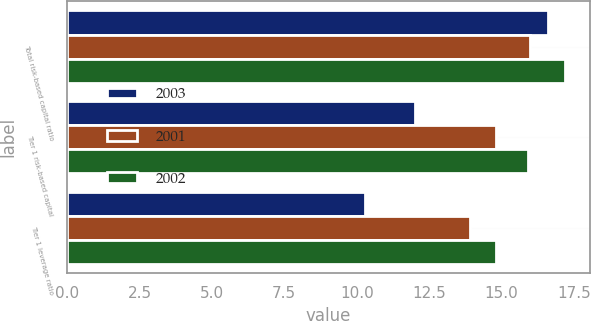Convert chart to OTSL. <chart><loc_0><loc_0><loc_500><loc_500><stacked_bar_chart><ecel><fcel>Total risk-based capital ratio<fcel>Tier 1 risk-based capital<fcel>Tier 1 leverage ratio<nl><fcel>2003<fcel>16.6<fcel>12<fcel>10.3<nl><fcel>2001<fcel>16<fcel>14.8<fcel>13.9<nl><fcel>2002<fcel>17.2<fcel>15.9<fcel>14.8<nl></chart> 